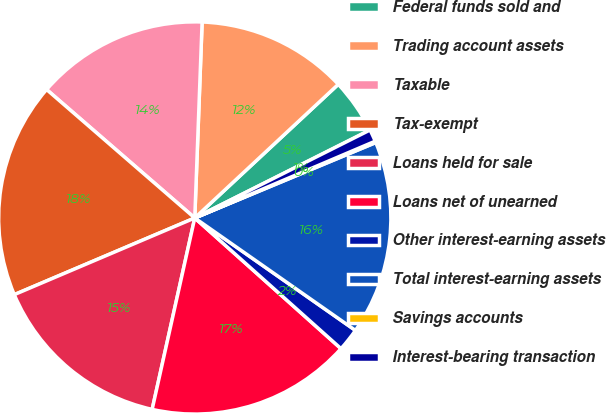Convert chart. <chart><loc_0><loc_0><loc_500><loc_500><pie_chart><fcel>Federal funds sold and<fcel>Trading account assets<fcel>Taxable<fcel>Tax-exempt<fcel>Loans held for sale<fcel>Loans net of unearned<fcel>Other interest-earning assets<fcel>Total interest-earning assets<fcel>Savings accounts<fcel>Interest-bearing transaction<nl><fcel>4.53%<fcel>12.47%<fcel>14.23%<fcel>17.76%<fcel>15.12%<fcel>16.88%<fcel>1.89%<fcel>16.0%<fcel>0.12%<fcel>1.0%<nl></chart> 